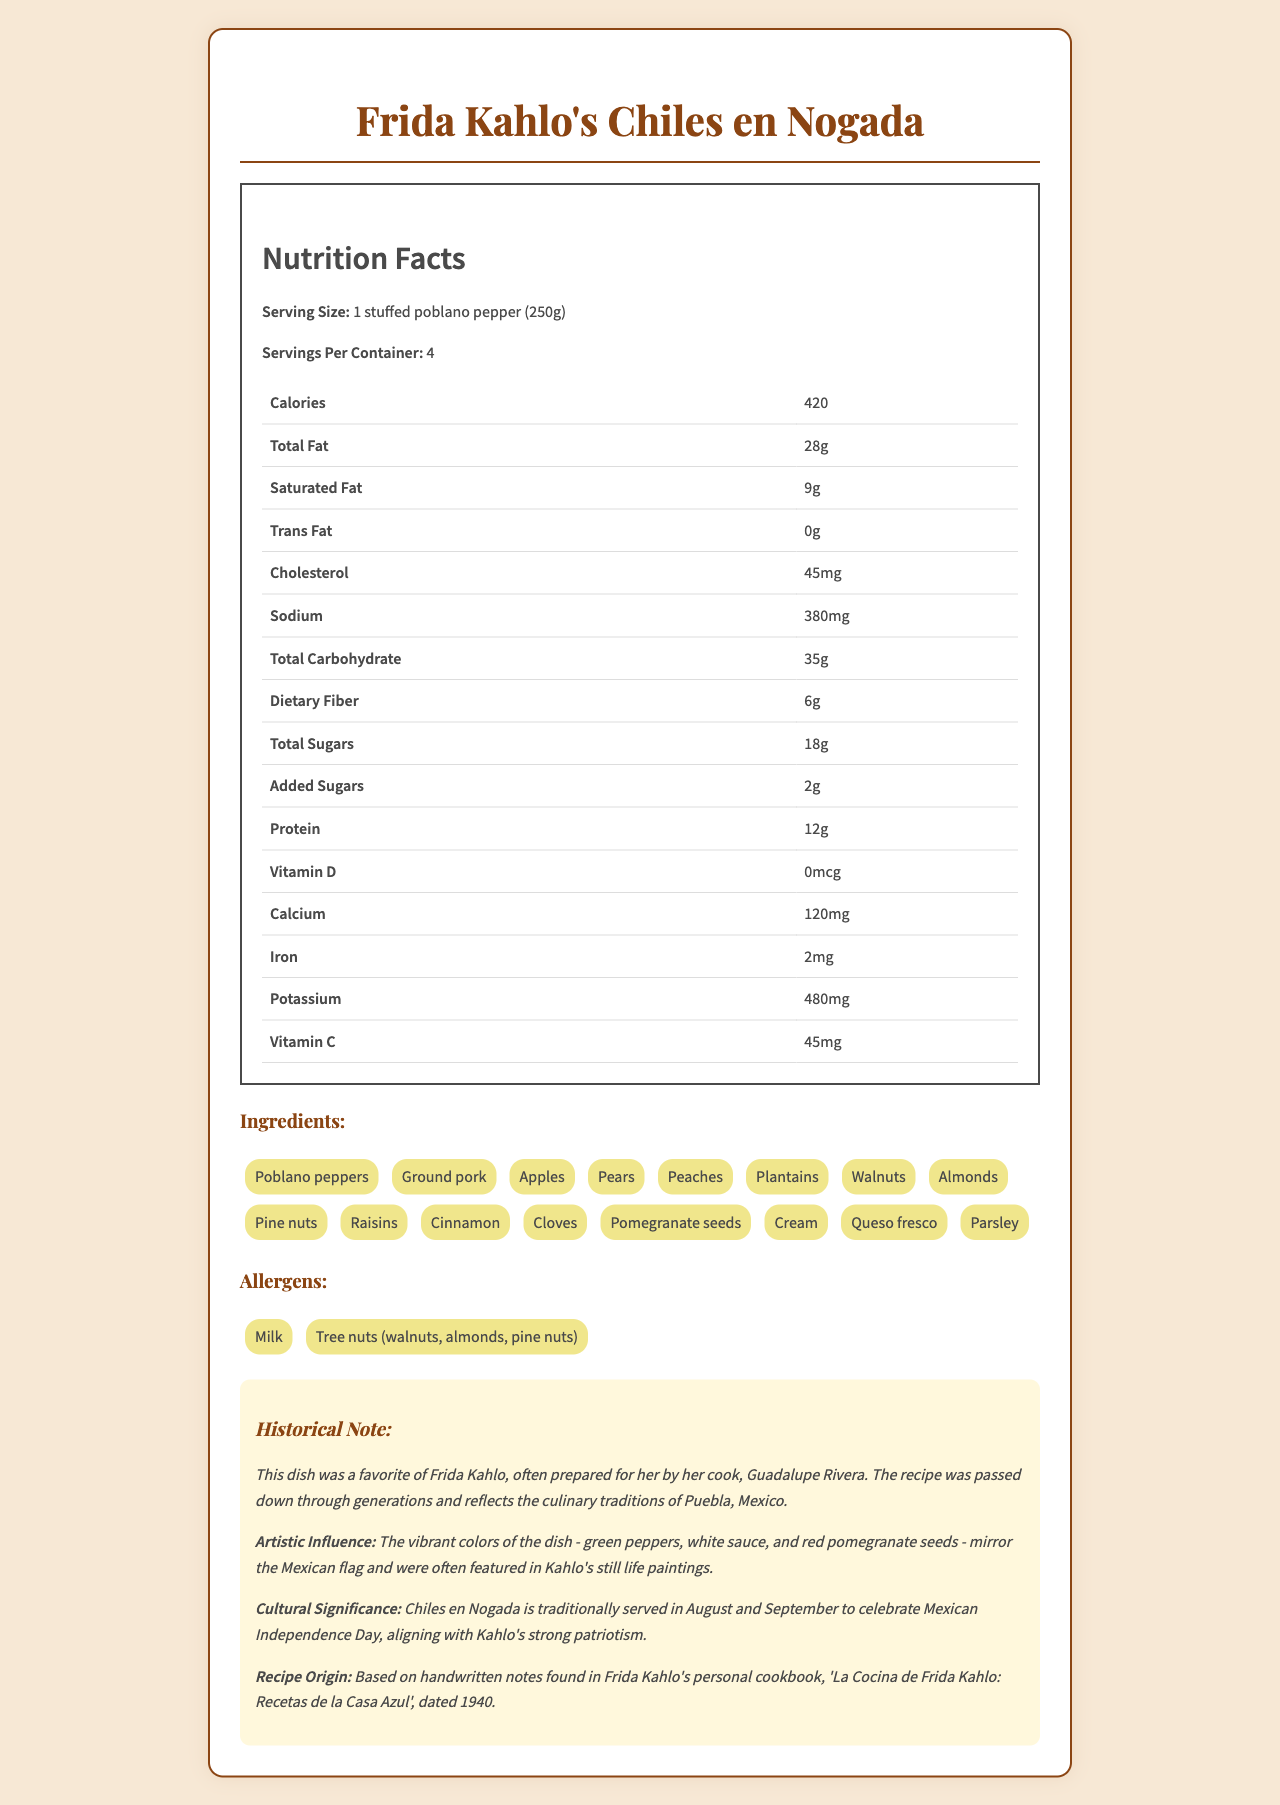what is the serving size? The serving size is explicitly mentioned at the beginning of the Nutrition Facts section.
Answer: 1 stuffed poblano pepper (250g) how many servings per container are there? The document states that there are 4 servings per container.
Answer: 4 how many grams of total fat are in one serving? The amount of total fat per serving is listed in the nutrition facts table.
Answer: 28g how much potassium is in one serving? The potassium content per serving is specified in the nutrition facts table.
Answer: 480mg how much dietary fiber is there in one serving? The dietary fiber content is listed in the nutrition facts section.
Answer: 6g what are the top three ingredients? A. Poblano peppers, Ground pork, Walnuts B. Poblano peppers, Ground pork, Apples C. Ground pork, Apples, Plantains D. Apples, Pears, Plantains The first three ingredients listed are Poblano peppers, Ground pork, and Apples.
Answer: B which of the following is an allergen present in the dish? I. Milk II. Gluten III. Soy IV. Tree nuts The allergens listed are Milk and Tree nuts.
Answer: I and IV is the amount of trans fat in the dish high? The document states that the amount of trans fat is 0g per serving, indicating there is no trans fat.
Answer: No does the dish have any added sugars? The document specifies that there are 2g of added sugars per serving.
Answer: Yes describe the historical significance of the dish in one sentence. This summary captures the key points about the historical note, artistic influence, and cultural significance mentioned in the document.
Answer: Chiles en Nogada was a favorite dish of Frida Kahlo, reflecting culinary traditions of Puebla and Mexican patriotism, often prepared by her cook Guadalupe Rivera and served to celebrate Mexican Independence Day. what is the preparation method for the dish? The preparation method is explicitly described in the document.
Answer: Roasted poblano peppers stuffed with a mixture of meat and fruits, topped with a walnut cream sauce and pomegranate seeds. what is the primary source of Vitamin C in the dish? The nutritional highlights mention that the dish is rich in Vitamin C from peppers and fruits.
Answer: Peppers and fruits how did Frida Kahlo's patriotism influence the dish? The cultural significance and artistic influence sections highlight these connections.
Answer: The dish is traditionally served to celebrate Mexican Independence Day with its colors mirroring the Mexican flag, aligning with Kahlo's strong patriotism. what is the publication date of the cookbook mentioned in the document? The recipe origin states that the handwritten notes were found in Frida Kahlo's personal cookbook dated 1940.
Answer: 1940 how many grams of protein are there in one serving? The protein content is listed in the nutrition facts section.
Answer: 12g which two ingredients are responsible for the walnut cream sauce? A. Walnuts and Cream B. Walnuts and Cinnamon C. Cream and Queso fresco D. Queso fresco and Walnuts The walnut cream sauce comprises Walnuts and Cream.
Answer: A what is the main idea of the document? The document aims to give complete information about the nutritional content, historical significance, ingredients, allergens, and cultural and artistic background of the dish.
Answer: The document provides a detailed nutritional breakdown and historical context of Frida Kahlo's favorite dish, Chiles en Nogada, highlighting its cultural significance and influences. who was Frida Kahlo's cook? The historical note mentions that the dish was often prepared for Frida Kahlo by her cook, Guadalupe Rivera.
Answer: Guadalupe Rivera what is the calorie content of one serving? The calorie content per serving is listed in the nutrition facts section.
Answer: 420 calories does the dish include any ingredients of animal origin? Ingredients like Ground pork and Cream include animal-origin elements.
Answer: Yes can the recipe origin be determined? The recipe origin is based on handwritten notes found in Frida Kahlo's personal cookbook from 1940.
Answer: Yes where did the culinary traditions of the dish come from? The historical note indicates that the dish reflects the culinary traditions of Puebla, Mexico.
Answer: Puebla, Mexico 